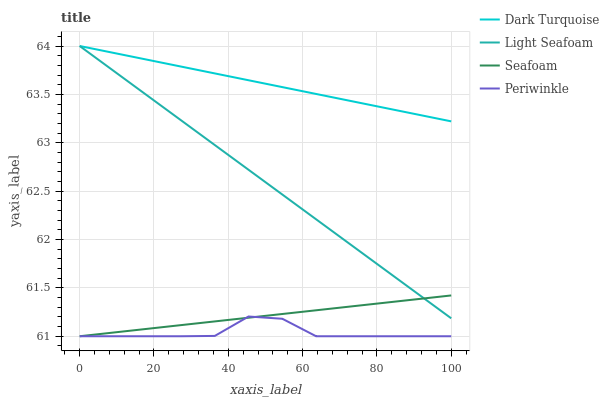Does Periwinkle have the minimum area under the curve?
Answer yes or no. Yes. Does Dark Turquoise have the maximum area under the curve?
Answer yes or no. Yes. Does Light Seafoam have the minimum area under the curve?
Answer yes or no. No. Does Light Seafoam have the maximum area under the curve?
Answer yes or no. No. Is Dark Turquoise the smoothest?
Answer yes or no. Yes. Is Periwinkle the roughest?
Answer yes or no. Yes. Is Light Seafoam the smoothest?
Answer yes or no. No. Is Light Seafoam the roughest?
Answer yes or no. No. Does Periwinkle have the lowest value?
Answer yes or no. Yes. Does Light Seafoam have the lowest value?
Answer yes or no. No. Does Light Seafoam have the highest value?
Answer yes or no. Yes. Does Periwinkle have the highest value?
Answer yes or no. No. Is Periwinkle less than Light Seafoam?
Answer yes or no. Yes. Is Dark Turquoise greater than Seafoam?
Answer yes or no. Yes. Does Seafoam intersect Periwinkle?
Answer yes or no. Yes. Is Seafoam less than Periwinkle?
Answer yes or no. No. Is Seafoam greater than Periwinkle?
Answer yes or no. No. Does Periwinkle intersect Light Seafoam?
Answer yes or no. No. 